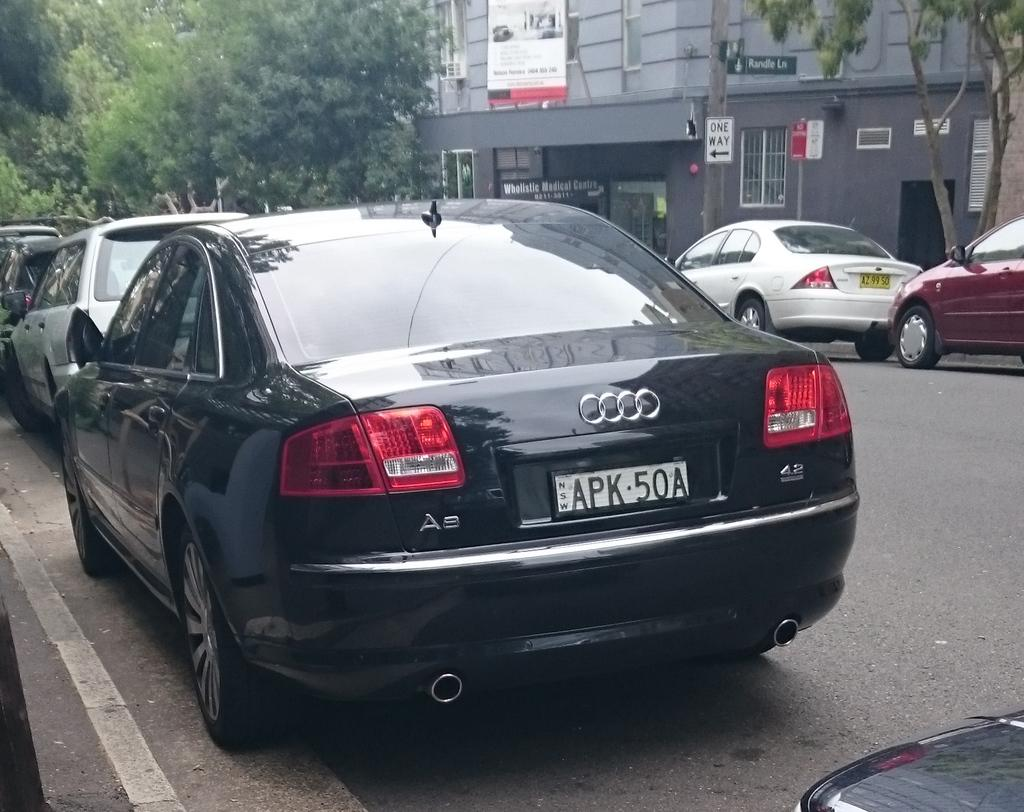What can be seen on both sides of the road in the image? There are cars parked on both sides of the road. What type of vegetation is visible in the top corners of the image? Trees are visible in the top right and left corners of the image. What type of structure is present in the image? There is a building with sign boards in the image. What is written on the sign boards? The sign boards have text on them. Can you see an apple falling from the tree in the image? There is no apple or tree with fruit visible in the image; only trees as vegetation are present. Is there an actor performing on the street in the image? There is no actor or performance taking place in the image; it features parked cars, trees, a building with sign boards, and text on the sign boards. 